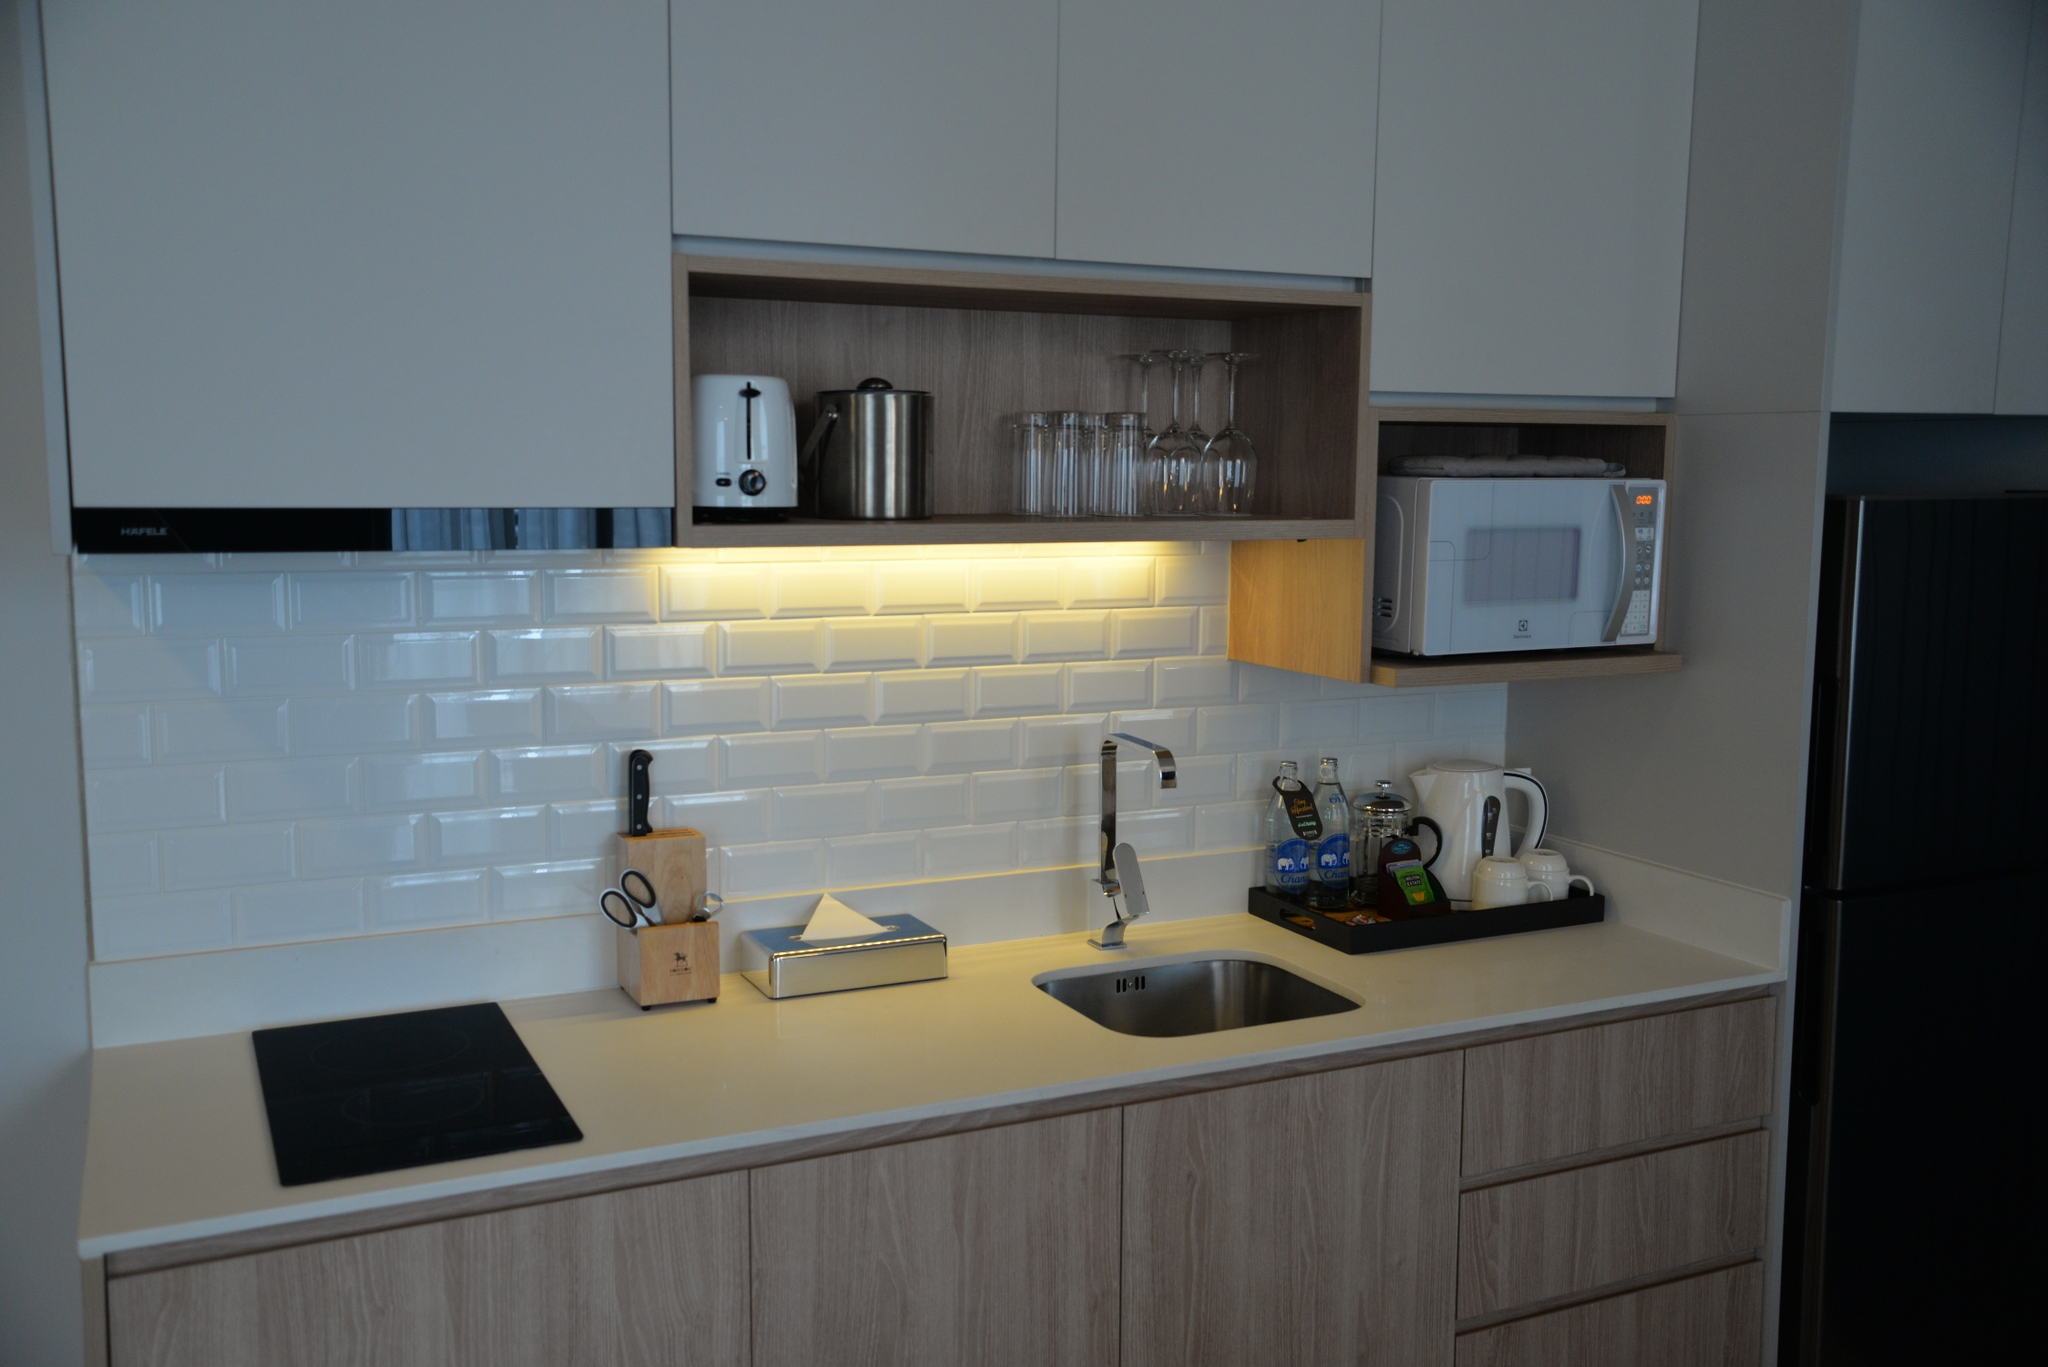What unique features stand out to you in this kitchen? The standout features of this kitchen include the use of elegant glass doors on some of the cabinets, which provide a peek into beautifully organized glassware. Another unique element is the sleek black induction cooktop that merges seamlessly with the light-gray countertop, adding a modern flair while being energy-efficient and easy to clean. The under-cabinet lighting is both practical and atmospheric, illuminating the workspace without the need for overhead lights. The arrangement of small appliances, such as the coffee maker and toaster, is both functional and visually appealing. Finally, the integration of the microwave and refrigerator into the cabinetry retains the kitchen's clean lines and minimalist aesthetic. 